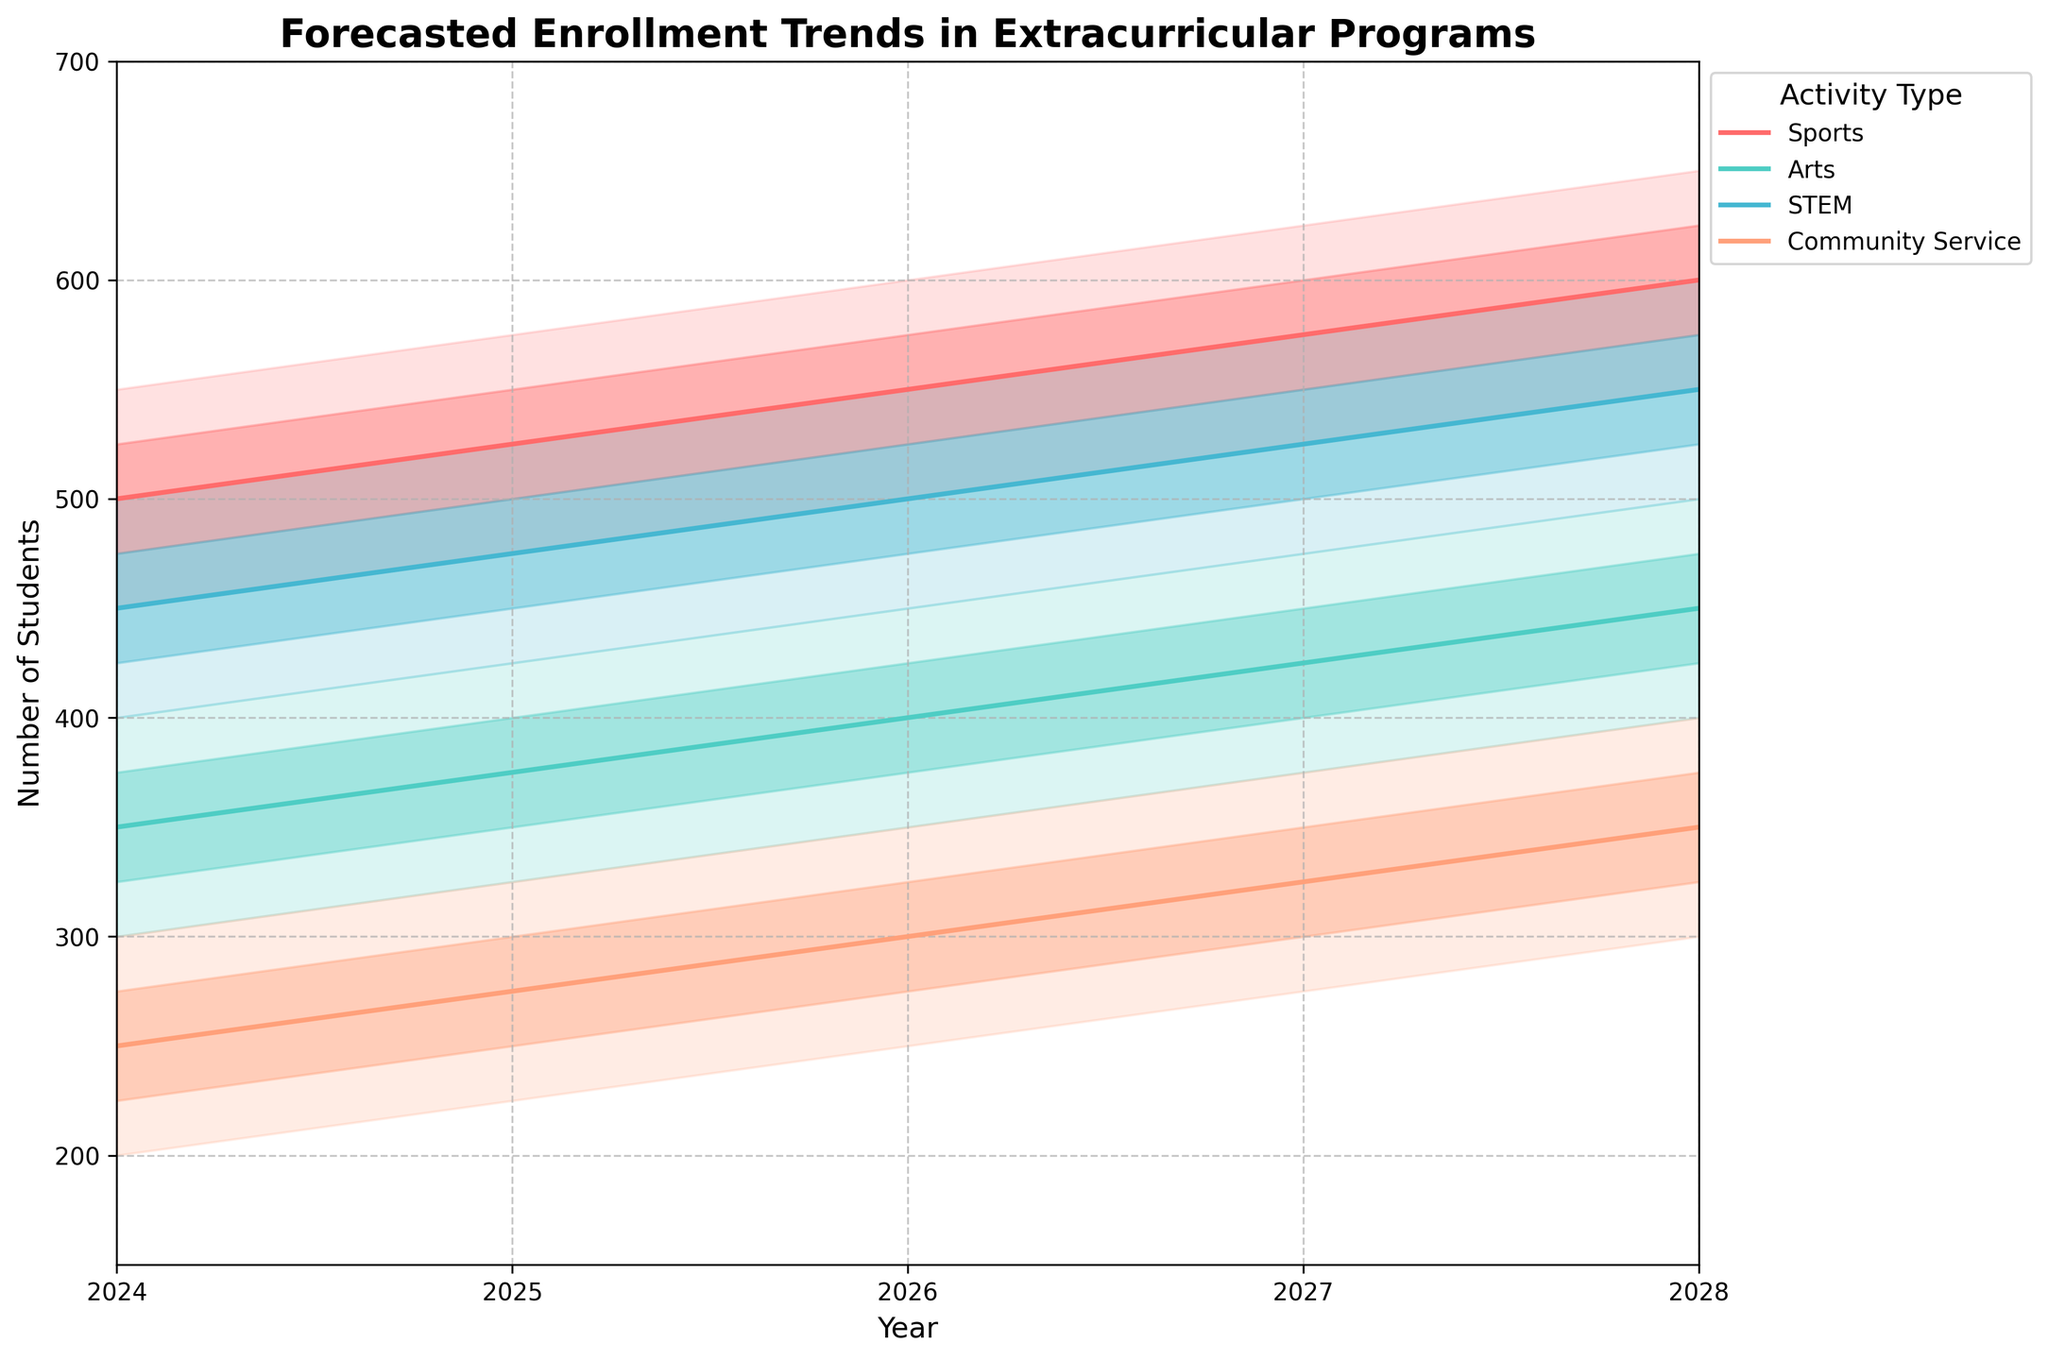What's the title of the figure? The title is located at the top of the chart and clearly states what information the chart is conveying.
Answer: Forecasted Enrollment Trends in Extracurricular Programs Which activity has the highest median enrollment forecasted in 2026? To find this, look at the median lines (solid lines) on the chart for each activity in the year 2026. The Sports line has the highest median value.
Answer: Sports What is the range of forecasted enrollments for Arts in 2025? The range can be found between the lowest and highest boundaries for Arts in 2025. The chart shows that for Arts in 2025, the range is from 325 to 425.
Answer: 325 to 425 How do the median forecasted enrollments for STEM in 2027 and 2028 compare? Look at the median lines for STEM in 2027 and 2028. The median forecasted enrollment is 525 in both years.
Answer: Equal Which activity shows the greatest increase in the median forecasted enrollment from 2024 to 2028? Track the median lines from 2024 to 2028 for each activity. The Sports line shows the highest increase from 500 to 600, which is an increase of 100.
Answer: Sports What is the interquartile range (IQR) for Community Service in 2027? The IQR is the difference between Q3 and Q1. For Community Service in 2027, Q3 is 350 and Q1 is 300. So, the IQR is 350-300.
Answer: 50 Which year shows a forecasted median enrollment of 400 for Arts? Scan the median line for Arts and look for the year where it touches 400. This happens in the year 2028.
Answer: 2028 Compare the forecasted enrollment variability for Sports and Arts in 2026. Which is more variable? The variability is indicated by the width of the bands between the low and high bounds. In 2026, the bands for Sports (500-600) are wider than for Arts (350-450).
Answer: Sports What trend do you observe in the median forecasted enrollments for Community Service from 2024 to 2028? The median line for Community Service shows a continuous increase from 250 in 2024 to 350 in 2028.
Answer: Increasing What's the Q1 forecasted enrollment for STEM in 2026? Find the Q1 value for STEM in 2026. According to the chart data, it's 475.
Answer: 475 